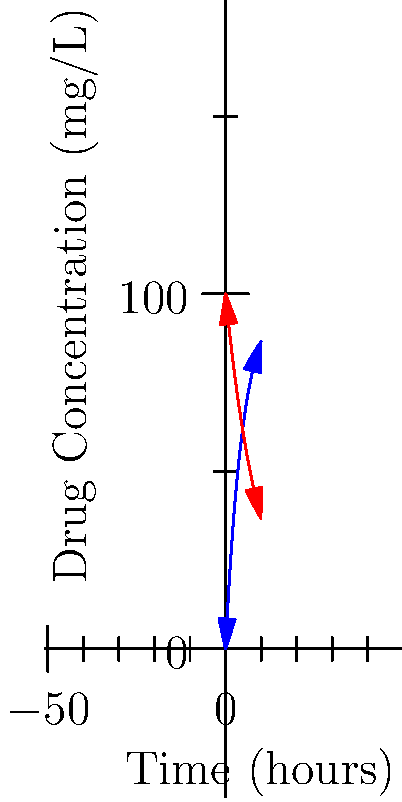The graph shows the absorption and elimination rates of a drug over time. The blue curve represents the absorption rate, while the red curve represents the elimination rate. If we consider these rates as velocity vectors, at what time (in hours) do these vectors have equal magnitude but opposite directions? To solve this problem, we need to follow these steps:

1) The absorption rate is given by the function: $A(t) = 100(1-e^{-0.2t})$
   The elimination rate is given by the function: $E(t) = 100e^{-0.1t}$

2) The velocity vectors will have equal magnitude but opposite directions when:
   $\frac{dA}{dt} = -\frac{dE}{dt}$

3) Let's calculate these derivatives:
   $\frac{dA}{dt} = 100(0.2e^{-0.2t}) = 20e^{-0.2t}$
   $\frac{dE}{dt} = 100(-0.1e^{-0.1t}) = -10e^{-0.1t}$

4) Setting these equal (with opposite signs):
   $20e^{-0.2t} = 10e^{-0.1t}$

5) Taking the natural log of both sides:
   $\ln(20) - 0.2t = \ln(10) - 0.1t$

6) Solving for t:
   $\ln(20) - \ln(10) = 0.1t$
   $\ln(2) = 0.1t$
   $t = \frac{\ln(2)}{0.1} \approx 6.93$ hours

Therefore, the velocity vectors have equal magnitude but opposite directions after approximately 6.93 hours.
Answer: 6.93 hours 